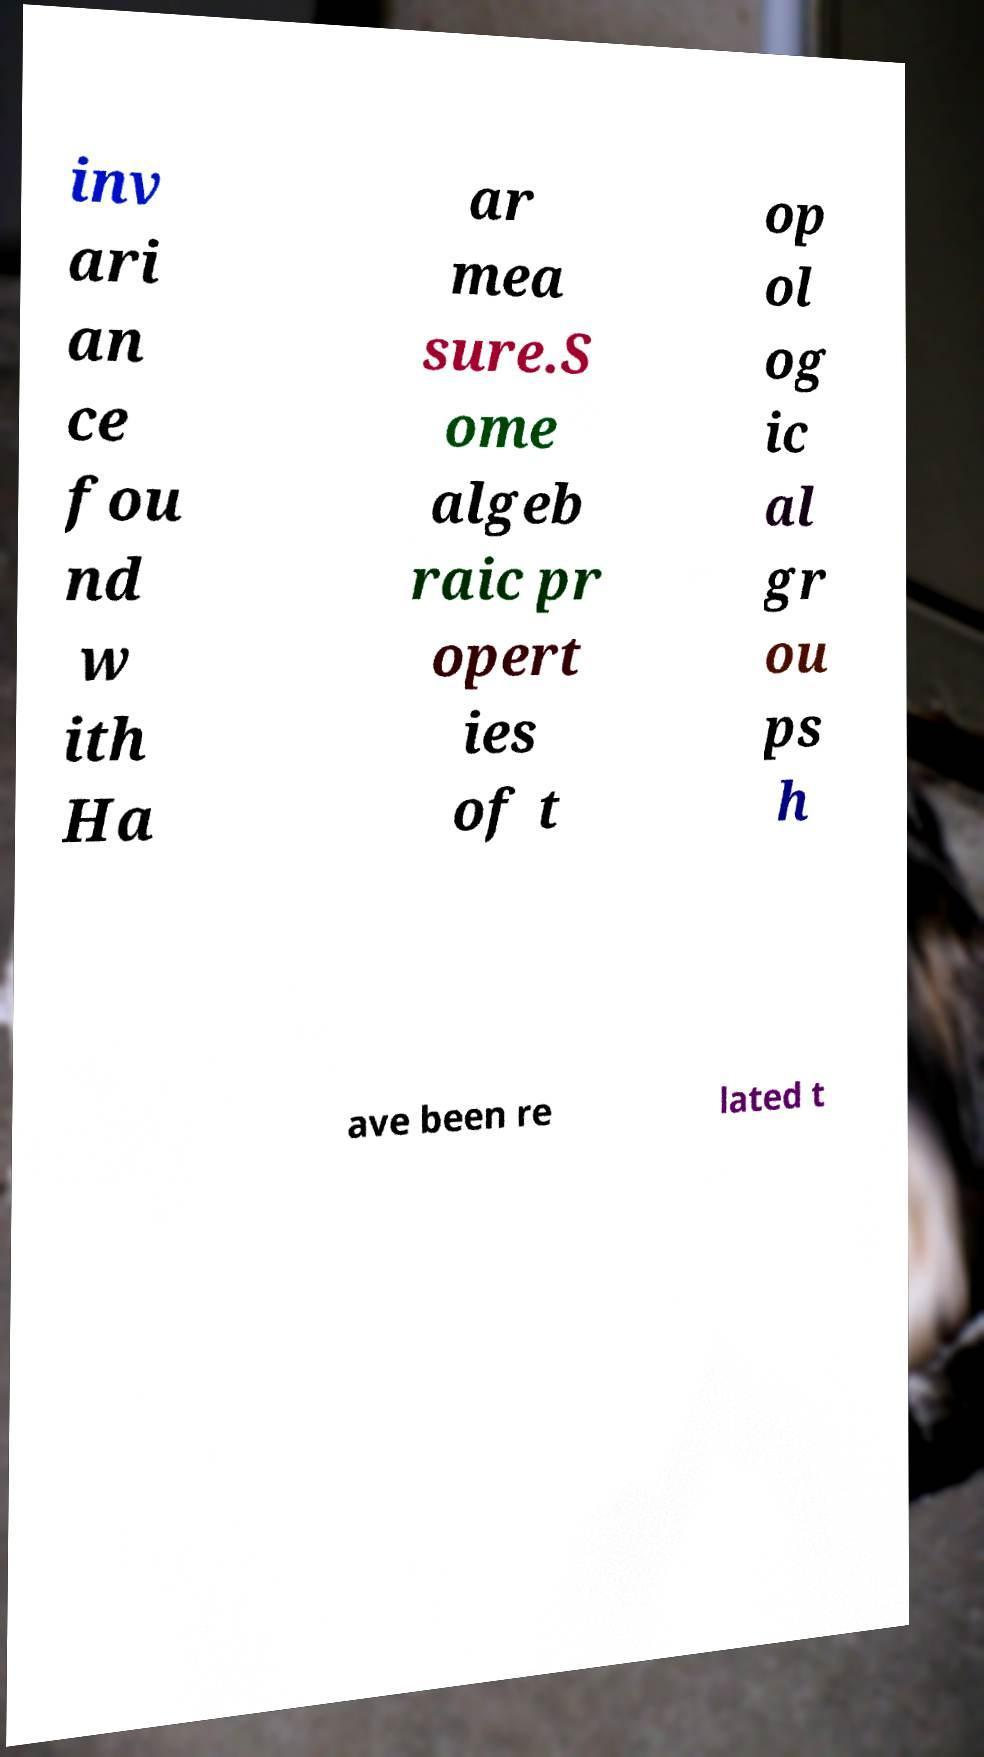Could you extract and type out the text from this image? inv ari an ce fou nd w ith Ha ar mea sure.S ome algeb raic pr opert ies of t op ol og ic al gr ou ps h ave been re lated t 